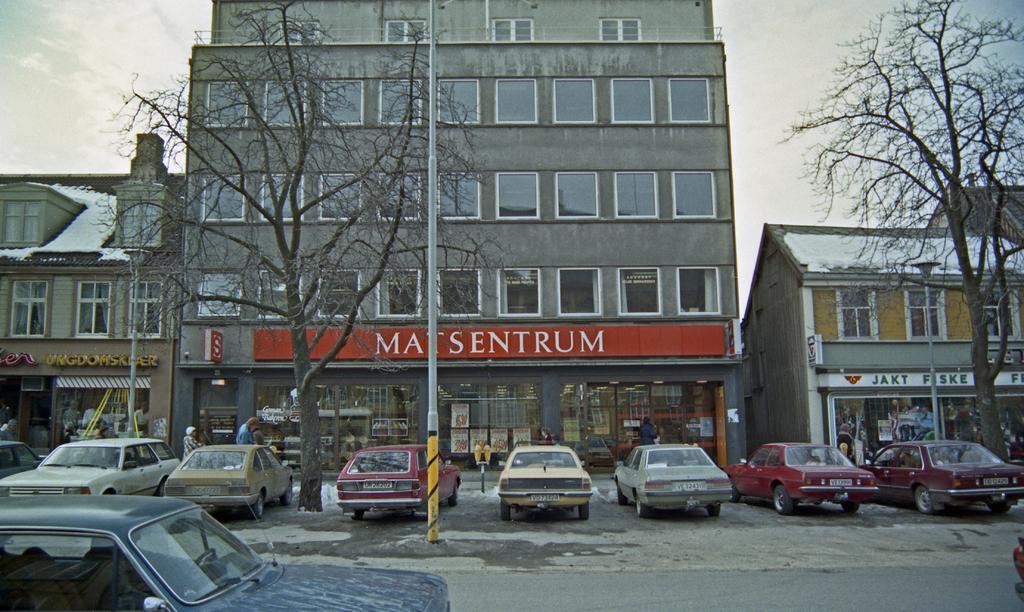Can you describe this image briefly? This image is clicked outside. There are buildings in the middle. There are cars at the bottom. There are trees in the middle. There is sky at the top. 